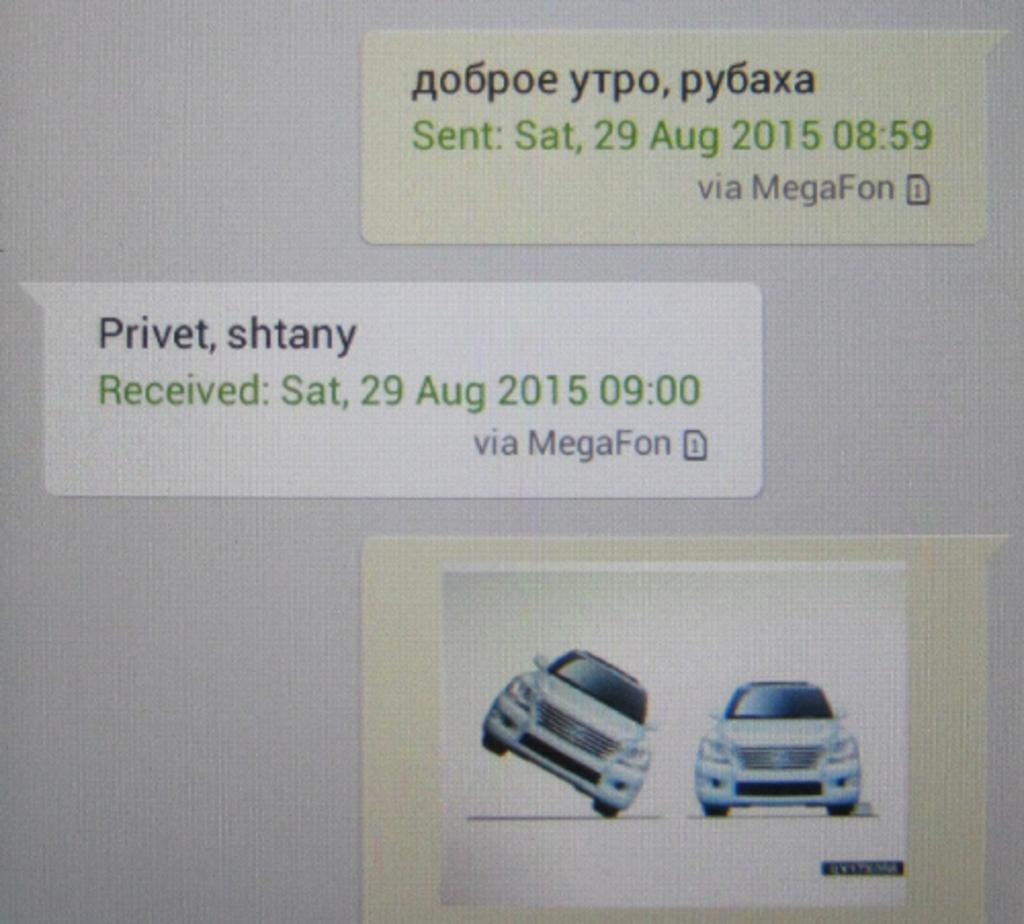What can be found on the labels in the image? The labels contain text and an image of two cars. What type of information is provided on the labels? The text on the labels provides information, but we cannot determine the specific details from the image alone. Can you describe the image on the labels? The image on the labels features two cars. What type of plant can be seen growing in the image? There is no plant visible in the image; it only contains labels with text and an image of two cars. 